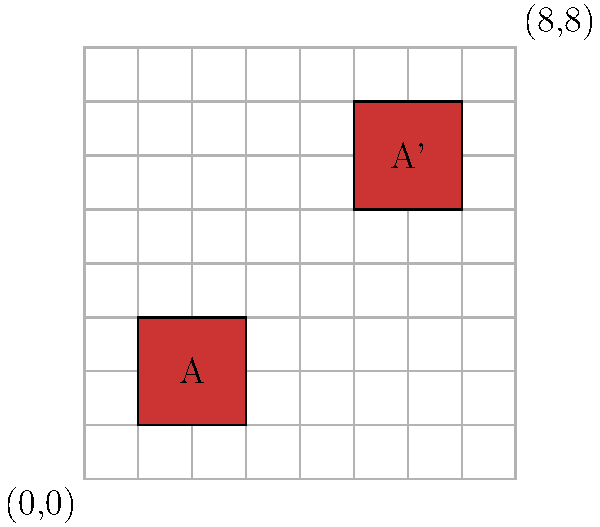You're designing a dance floor pattern for your local community center's teen night. The pattern is based on translating a square shape across the floor. In the diagram, square A is translated to create square A'. If the coordinates of the bottom-left corner of square A are $(1,1)$, what are the coordinates of the bottom-left corner of square A'? Let's approach this step-by-step:

1) First, we need to identify the translation vector. We can do this by observing how square A has moved to become square A'.

2) Looking at the grid, we can see that square A has moved 4 units to the right and 4 units up.

3) This means the translation vector is $(4,4)$.

4) Now, we need to apply this translation to the coordinates of the bottom-left corner of square A.

5) The coordinates of the bottom-left corner of square A are $(1,1)$.

6) To translate a point, we add the translation vector to the original coordinates:
   $$(x,y) + (a,b) = (x+a, y+b)$$

7) In this case:
   $$(1,1) + (4,4) = (1+4, 1+4) = (5,5)$$

Therefore, the coordinates of the bottom-left corner of square A' are $(5,5)$.
Answer: $(5,5)$ 